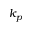Convert formula to latex. <formula><loc_0><loc_0><loc_500><loc_500>k _ { p }</formula> 